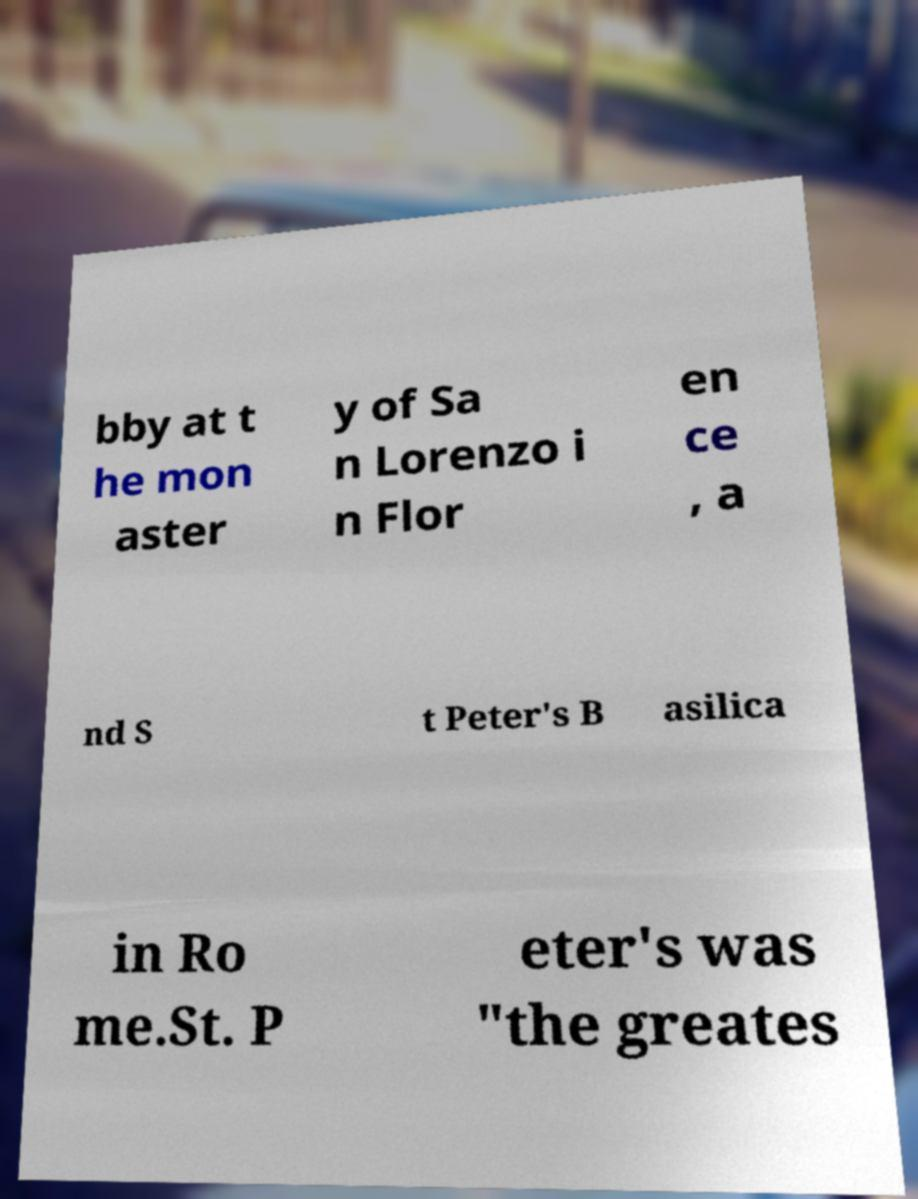Could you assist in decoding the text presented in this image and type it out clearly? bby at t he mon aster y of Sa n Lorenzo i n Flor en ce , a nd S t Peter's B asilica in Ro me.St. P eter's was "the greates 